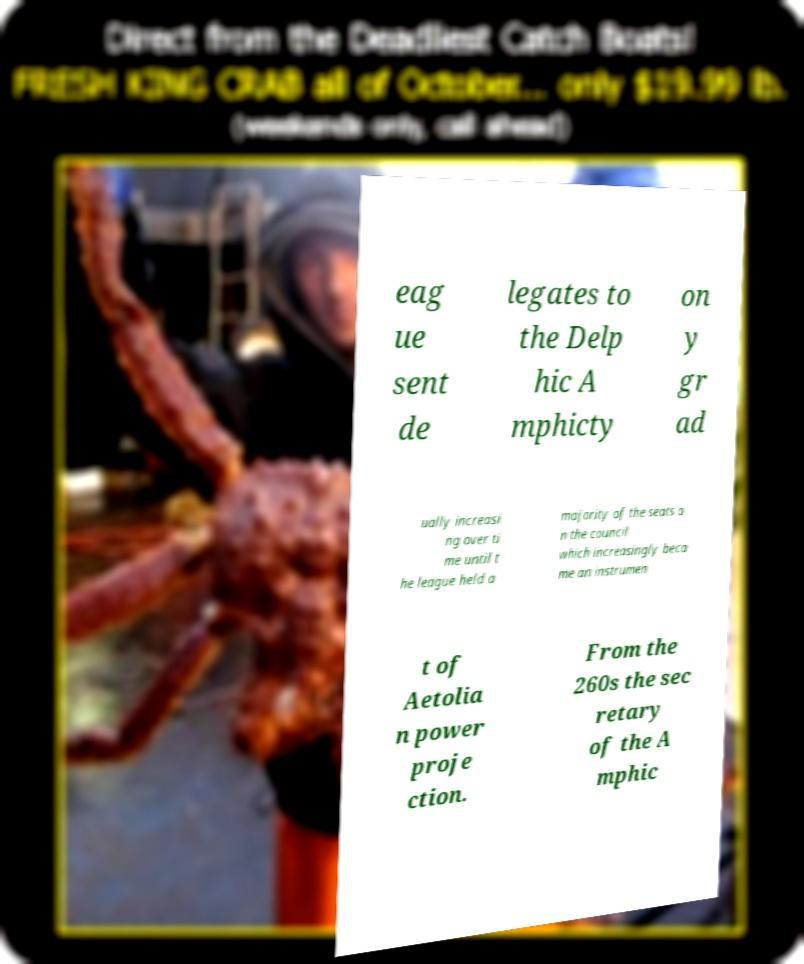There's text embedded in this image that I need extracted. Can you transcribe it verbatim? eag ue sent de legates to the Delp hic A mphicty on y gr ad ually increasi ng over ti me until t he league held a majority of the seats o n the council which increasingly beca me an instrumen t of Aetolia n power proje ction. From the 260s the sec retary of the A mphic 